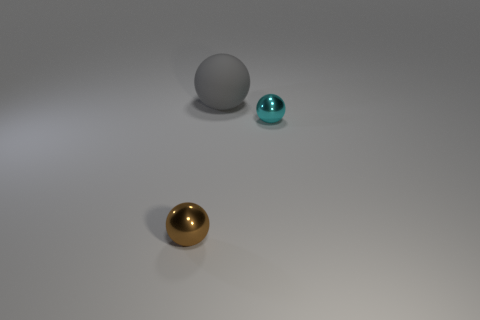What number of cylinders are either small brown objects or shiny things?
Offer a very short reply. 0. There is a metal sphere that is to the left of the matte sphere; what is its color?
Provide a short and direct response. Brown. There is a cyan metallic thing that is the same size as the brown metallic thing; what shape is it?
Make the answer very short. Sphere. How many small balls are to the left of the tiny brown object?
Your response must be concise. 0. How many things are either cyan spheres or brown metal objects?
Your answer should be very brief. 2. There is a object that is on the left side of the cyan shiny object and in front of the large ball; what shape is it?
Ensure brevity in your answer.  Sphere. What number of big brown blocks are there?
Your response must be concise. 0. What is the color of the small thing that is the same material as the cyan sphere?
Your response must be concise. Brown. Is the number of tiny shiny things greater than the number of small cyan metal objects?
Your answer should be compact. Yes. There is a ball that is in front of the large sphere and left of the cyan metallic sphere; how big is it?
Make the answer very short. Small. 